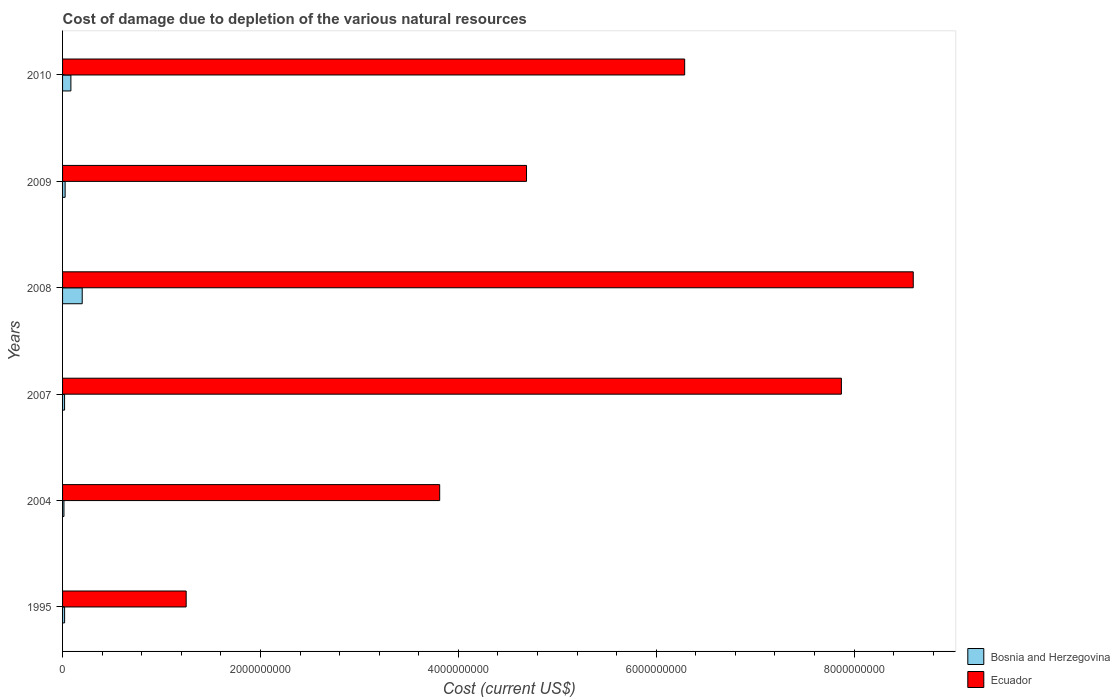How many different coloured bars are there?
Provide a succinct answer. 2. How many bars are there on the 4th tick from the top?
Your response must be concise. 2. How many bars are there on the 6th tick from the bottom?
Provide a succinct answer. 2. What is the cost of damage caused due to the depletion of various natural resources in Bosnia and Herzegovina in 2010?
Give a very brief answer. 8.42e+07. Across all years, what is the maximum cost of damage caused due to the depletion of various natural resources in Ecuador?
Keep it short and to the point. 8.60e+09. Across all years, what is the minimum cost of damage caused due to the depletion of various natural resources in Bosnia and Herzegovina?
Offer a terse response. 1.40e+07. What is the total cost of damage caused due to the depletion of various natural resources in Ecuador in the graph?
Offer a very short reply. 3.25e+1. What is the difference between the cost of damage caused due to the depletion of various natural resources in Bosnia and Herzegovina in 2004 and that in 2009?
Your answer should be compact. -1.18e+07. What is the difference between the cost of damage caused due to the depletion of various natural resources in Ecuador in 2009 and the cost of damage caused due to the depletion of various natural resources in Bosnia and Herzegovina in 2008?
Give a very brief answer. 4.49e+09. What is the average cost of damage caused due to the depletion of various natural resources in Bosnia and Herzegovina per year?
Give a very brief answer. 6.06e+07. In the year 2008, what is the difference between the cost of damage caused due to the depletion of various natural resources in Ecuador and cost of damage caused due to the depletion of various natural resources in Bosnia and Herzegovina?
Your response must be concise. 8.40e+09. In how many years, is the cost of damage caused due to the depletion of various natural resources in Ecuador greater than 3600000000 US$?
Offer a very short reply. 5. What is the ratio of the cost of damage caused due to the depletion of various natural resources in Bosnia and Herzegovina in 2009 to that in 2010?
Your response must be concise. 0.31. Is the cost of damage caused due to the depletion of various natural resources in Bosnia and Herzegovina in 1995 less than that in 2008?
Offer a terse response. Yes. Is the difference between the cost of damage caused due to the depletion of various natural resources in Ecuador in 1995 and 2007 greater than the difference between the cost of damage caused due to the depletion of various natural resources in Bosnia and Herzegovina in 1995 and 2007?
Provide a succinct answer. No. What is the difference between the highest and the second highest cost of damage caused due to the depletion of various natural resources in Bosnia and Herzegovina?
Provide a short and direct response. 1.14e+08. What is the difference between the highest and the lowest cost of damage caused due to the depletion of various natural resources in Bosnia and Herzegovina?
Offer a terse response. 1.85e+08. Is the sum of the cost of damage caused due to the depletion of various natural resources in Bosnia and Herzegovina in 1995 and 2008 greater than the maximum cost of damage caused due to the depletion of various natural resources in Ecuador across all years?
Make the answer very short. No. What does the 2nd bar from the top in 2010 represents?
Your answer should be very brief. Bosnia and Herzegovina. What does the 1st bar from the bottom in 1995 represents?
Give a very brief answer. Bosnia and Herzegovina. How many bars are there?
Provide a short and direct response. 12. Are all the bars in the graph horizontal?
Your response must be concise. Yes. What is the difference between two consecutive major ticks on the X-axis?
Your answer should be very brief. 2.00e+09. Are the values on the major ticks of X-axis written in scientific E-notation?
Give a very brief answer. No. Does the graph contain any zero values?
Make the answer very short. No. Does the graph contain grids?
Offer a terse response. No. Where does the legend appear in the graph?
Offer a terse response. Bottom right. How many legend labels are there?
Your response must be concise. 2. How are the legend labels stacked?
Give a very brief answer. Vertical. What is the title of the graph?
Provide a short and direct response. Cost of damage due to depletion of the various natural resources. What is the label or title of the X-axis?
Make the answer very short. Cost (current US$). What is the Cost (current US$) of Bosnia and Herzegovina in 1995?
Give a very brief answer. 2.06e+07. What is the Cost (current US$) of Ecuador in 1995?
Provide a succinct answer. 1.25e+09. What is the Cost (current US$) of Bosnia and Herzegovina in 2004?
Offer a terse response. 1.40e+07. What is the Cost (current US$) of Ecuador in 2004?
Offer a terse response. 3.81e+09. What is the Cost (current US$) in Bosnia and Herzegovina in 2007?
Your response must be concise. 2.04e+07. What is the Cost (current US$) in Ecuador in 2007?
Provide a short and direct response. 7.87e+09. What is the Cost (current US$) in Bosnia and Herzegovina in 2008?
Offer a very short reply. 1.99e+08. What is the Cost (current US$) in Ecuador in 2008?
Ensure brevity in your answer.  8.60e+09. What is the Cost (current US$) of Bosnia and Herzegovina in 2009?
Offer a very short reply. 2.58e+07. What is the Cost (current US$) in Ecuador in 2009?
Ensure brevity in your answer.  4.69e+09. What is the Cost (current US$) in Bosnia and Herzegovina in 2010?
Your answer should be compact. 8.42e+07. What is the Cost (current US$) of Ecuador in 2010?
Provide a succinct answer. 6.29e+09. Across all years, what is the maximum Cost (current US$) in Bosnia and Herzegovina?
Offer a very short reply. 1.99e+08. Across all years, what is the maximum Cost (current US$) in Ecuador?
Ensure brevity in your answer.  8.60e+09. Across all years, what is the minimum Cost (current US$) of Bosnia and Herzegovina?
Offer a very short reply. 1.40e+07. Across all years, what is the minimum Cost (current US$) of Ecuador?
Offer a terse response. 1.25e+09. What is the total Cost (current US$) in Bosnia and Herzegovina in the graph?
Keep it short and to the point. 3.64e+08. What is the total Cost (current US$) of Ecuador in the graph?
Keep it short and to the point. 3.25e+1. What is the difference between the Cost (current US$) in Bosnia and Herzegovina in 1995 and that in 2004?
Provide a short and direct response. 6.60e+06. What is the difference between the Cost (current US$) in Ecuador in 1995 and that in 2004?
Offer a terse response. -2.56e+09. What is the difference between the Cost (current US$) of Bosnia and Herzegovina in 1995 and that in 2007?
Keep it short and to the point. 2.36e+05. What is the difference between the Cost (current US$) in Ecuador in 1995 and that in 2007?
Provide a short and direct response. -6.62e+09. What is the difference between the Cost (current US$) in Bosnia and Herzegovina in 1995 and that in 2008?
Offer a terse response. -1.78e+08. What is the difference between the Cost (current US$) in Ecuador in 1995 and that in 2008?
Offer a terse response. -7.35e+09. What is the difference between the Cost (current US$) of Bosnia and Herzegovina in 1995 and that in 2009?
Ensure brevity in your answer.  -5.19e+06. What is the difference between the Cost (current US$) in Ecuador in 1995 and that in 2009?
Keep it short and to the point. -3.44e+09. What is the difference between the Cost (current US$) of Bosnia and Herzegovina in 1995 and that in 2010?
Make the answer very short. -6.35e+07. What is the difference between the Cost (current US$) in Ecuador in 1995 and that in 2010?
Provide a short and direct response. -5.04e+09. What is the difference between the Cost (current US$) in Bosnia and Herzegovina in 2004 and that in 2007?
Provide a short and direct response. -6.36e+06. What is the difference between the Cost (current US$) in Ecuador in 2004 and that in 2007?
Ensure brevity in your answer.  -4.06e+09. What is the difference between the Cost (current US$) in Bosnia and Herzegovina in 2004 and that in 2008?
Make the answer very short. -1.85e+08. What is the difference between the Cost (current US$) of Ecuador in 2004 and that in 2008?
Offer a terse response. -4.79e+09. What is the difference between the Cost (current US$) of Bosnia and Herzegovina in 2004 and that in 2009?
Provide a succinct answer. -1.18e+07. What is the difference between the Cost (current US$) of Ecuador in 2004 and that in 2009?
Offer a very short reply. -8.78e+08. What is the difference between the Cost (current US$) in Bosnia and Herzegovina in 2004 and that in 2010?
Your answer should be very brief. -7.01e+07. What is the difference between the Cost (current US$) in Ecuador in 2004 and that in 2010?
Give a very brief answer. -2.48e+09. What is the difference between the Cost (current US$) of Bosnia and Herzegovina in 2007 and that in 2008?
Provide a succinct answer. -1.78e+08. What is the difference between the Cost (current US$) of Ecuador in 2007 and that in 2008?
Make the answer very short. -7.26e+08. What is the difference between the Cost (current US$) of Bosnia and Herzegovina in 2007 and that in 2009?
Give a very brief answer. -5.43e+06. What is the difference between the Cost (current US$) of Ecuador in 2007 and that in 2009?
Your answer should be very brief. 3.18e+09. What is the difference between the Cost (current US$) of Bosnia and Herzegovina in 2007 and that in 2010?
Offer a terse response. -6.38e+07. What is the difference between the Cost (current US$) in Ecuador in 2007 and that in 2010?
Make the answer very short. 1.58e+09. What is the difference between the Cost (current US$) in Bosnia and Herzegovina in 2008 and that in 2009?
Your answer should be compact. 1.73e+08. What is the difference between the Cost (current US$) in Ecuador in 2008 and that in 2009?
Your response must be concise. 3.91e+09. What is the difference between the Cost (current US$) of Bosnia and Herzegovina in 2008 and that in 2010?
Offer a terse response. 1.14e+08. What is the difference between the Cost (current US$) in Ecuador in 2008 and that in 2010?
Ensure brevity in your answer.  2.31e+09. What is the difference between the Cost (current US$) of Bosnia and Herzegovina in 2009 and that in 2010?
Provide a succinct answer. -5.83e+07. What is the difference between the Cost (current US$) in Ecuador in 2009 and that in 2010?
Your answer should be compact. -1.60e+09. What is the difference between the Cost (current US$) in Bosnia and Herzegovina in 1995 and the Cost (current US$) in Ecuador in 2004?
Your answer should be very brief. -3.79e+09. What is the difference between the Cost (current US$) in Bosnia and Herzegovina in 1995 and the Cost (current US$) in Ecuador in 2007?
Your answer should be very brief. -7.85e+09. What is the difference between the Cost (current US$) in Bosnia and Herzegovina in 1995 and the Cost (current US$) in Ecuador in 2008?
Ensure brevity in your answer.  -8.58e+09. What is the difference between the Cost (current US$) in Bosnia and Herzegovina in 1995 and the Cost (current US$) in Ecuador in 2009?
Keep it short and to the point. -4.67e+09. What is the difference between the Cost (current US$) of Bosnia and Herzegovina in 1995 and the Cost (current US$) of Ecuador in 2010?
Your answer should be very brief. -6.27e+09. What is the difference between the Cost (current US$) of Bosnia and Herzegovina in 2004 and the Cost (current US$) of Ecuador in 2007?
Give a very brief answer. -7.86e+09. What is the difference between the Cost (current US$) of Bosnia and Herzegovina in 2004 and the Cost (current US$) of Ecuador in 2008?
Make the answer very short. -8.58e+09. What is the difference between the Cost (current US$) of Bosnia and Herzegovina in 2004 and the Cost (current US$) of Ecuador in 2009?
Provide a short and direct response. -4.68e+09. What is the difference between the Cost (current US$) in Bosnia and Herzegovina in 2004 and the Cost (current US$) in Ecuador in 2010?
Keep it short and to the point. -6.27e+09. What is the difference between the Cost (current US$) in Bosnia and Herzegovina in 2007 and the Cost (current US$) in Ecuador in 2008?
Offer a very short reply. -8.58e+09. What is the difference between the Cost (current US$) in Bosnia and Herzegovina in 2007 and the Cost (current US$) in Ecuador in 2009?
Your answer should be very brief. -4.67e+09. What is the difference between the Cost (current US$) in Bosnia and Herzegovina in 2007 and the Cost (current US$) in Ecuador in 2010?
Your answer should be very brief. -6.27e+09. What is the difference between the Cost (current US$) in Bosnia and Herzegovina in 2008 and the Cost (current US$) in Ecuador in 2009?
Your answer should be very brief. -4.49e+09. What is the difference between the Cost (current US$) in Bosnia and Herzegovina in 2008 and the Cost (current US$) in Ecuador in 2010?
Provide a succinct answer. -6.09e+09. What is the difference between the Cost (current US$) in Bosnia and Herzegovina in 2009 and the Cost (current US$) in Ecuador in 2010?
Give a very brief answer. -6.26e+09. What is the average Cost (current US$) of Bosnia and Herzegovina per year?
Make the answer very short. 6.06e+07. What is the average Cost (current US$) of Ecuador per year?
Offer a terse response. 5.42e+09. In the year 1995, what is the difference between the Cost (current US$) in Bosnia and Herzegovina and Cost (current US$) in Ecuador?
Keep it short and to the point. -1.23e+09. In the year 2004, what is the difference between the Cost (current US$) of Bosnia and Herzegovina and Cost (current US$) of Ecuador?
Your response must be concise. -3.80e+09. In the year 2007, what is the difference between the Cost (current US$) of Bosnia and Herzegovina and Cost (current US$) of Ecuador?
Offer a very short reply. -7.85e+09. In the year 2008, what is the difference between the Cost (current US$) of Bosnia and Herzegovina and Cost (current US$) of Ecuador?
Ensure brevity in your answer.  -8.40e+09. In the year 2009, what is the difference between the Cost (current US$) of Bosnia and Herzegovina and Cost (current US$) of Ecuador?
Provide a short and direct response. -4.66e+09. In the year 2010, what is the difference between the Cost (current US$) in Bosnia and Herzegovina and Cost (current US$) in Ecuador?
Offer a very short reply. -6.20e+09. What is the ratio of the Cost (current US$) in Bosnia and Herzegovina in 1995 to that in 2004?
Your answer should be very brief. 1.47. What is the ratio of the Cost (current US$) of Ecuador in 1995 to that in 2004?
Provide a short and direct response. 0.33. What is the ratio of the Cost (current US$) in Bosnia and Herzegovina in 1995 to that in 2007?
Your answer should be compact. 1.01. What is the ratio of the Cost (current US$) of Ecuador in 1995 to that in 2007?
Offer a very short reply. 0.16. What is the ratio of the Cost (current US$) of Bosnia and Herzegovina in 1995 to that in 2008?
Your response must be concise. 0.1. What is the ratio of the Cost (current US$) of Ecuador in 1995 to that in 2008?
Offer a very short reply. 0.15. What is the ratio of the Cost (current US$) in Bosnia and Herzegovina in 1995 to that in 2009?
Provide a short and direct response. 0.8. What is the ratio of the Cost (current US$) of Ecuador in 1995 to that in 2009?
Provide a short and direct response. 0.27. What is the ratio of the Cost (current US$) in Bosnia and Herzegovina in 1995 to that in 2010?
Offer a very short reply. 0.25. What is the ratio of the Cost (current US$) of Ecuador in 1995 to that in 2010?
Your answer should be very brief. 0.2. What is the ratio of the Cost (current US$) in Bosnia and Herzegovina in 2004 to that in 2007?
Your answer should be compact. 0.69. What is the ratio of the Cost (current US$) in Ecuador in 2004 to that in 2007?
Your response must be concise. 0.48. What is the ratio of the Cost (current US$) in Bosnia and Herzegovina in 2004 to that in 2008?
Your response must be concise. 0.07. What is the ratio of the Cost (current US$) of Ecuador in 2004 to that in 2008?
Ensure brevity in your answer.  0.44. What is the ratio of the Cost (current US$) in Bosnia and Herzegovina in 2004 to that in 2009?
Your response must be concise. 0.54. What is the ratio of the Cost (current US$) of Ecuador in 2004 to that in 2009?
Ensure brevity in your answer.  0.81. What is the ratio of the Cost (current US$) in Bosnia and Herzegovina in 2004 to that in 2010?
Give a very brief answer. 0.17. What is the ratio of the Cost (current US$) of Ecuador in 2004 to that in 2010?
Give a very brief answer. 0.61. What is the ratio of the Cost (current US$) of Bosnia and Herzegovina in 2007 to that in 2008?
Your answer should be compact. 0.1. What is the ratio of the Cost (current US$) of Ecuador in 2007 to that in 2008?
Give a very brief answer. 0.92. What is the ratio of the Cost (current US$) of Bosnia and Herzegovina in 2007 to that in 2009?
Provide a succinct answer. 0.79. What is the ratio of the Cost (current US$) in Ecuador in 2007 to that in 2009?
Offer a very short reply. 1.68. What is the ratio of the Cost (current US$) in Bosnia and Herzegovina in 2007 to that in 2010?
Make the answer very short. 0.24. What is the ratio of the Cost (current US$) in Ecuador in 2007 to that in 2010?
Your answer should be compact. 1.25. What is the ratio of the Cost (current US$) in Bosnia and Herzegovina in 2008 to that in 2009?
Provide a succinct answer. 7.69. What is the ratio of the Cost (current US$) in Ecuador in 2008 to that in 2009?
Provide a short and direct response. 1.83. What is the ratio of the Cost (current US$) in Bosnia and Herzegovina in 2008 to that in 2010?
Your answer should be compact. 2.36. What is the ratio of the Cost (current US$) in Ecuador in 2008 to that in 2010?
Provide a succinct answer. 1.37. What is the ratio of the Cost (current US$) in Bosnia and Herzegovina in 2009 to that in 2010?
Keep it short and to the point. 0.31. What is the ratio of the Cost (current US$) in Ecuador in 2009 to that in 2010?
Your response must be concise. 0.75. What is the difference between the highest and the second highest Cost (current US$) of Bosnia and Herzegovina?
Make the answer very short. 1.14e+08. What is the difference between the highest and the second highest Cost (current US$) in Ecuador?
Give a very brief answer. 7.26e+08. What is the difference between the highest and the lowest Cost (current US$) of Bosnia and Herzegovina?
Provide a succinct answer. 1.85e+08. What is the difference between the highest and the lowest Cost (current US$) of Ecuador?
Offer a very short reply. 7.35e+09. 